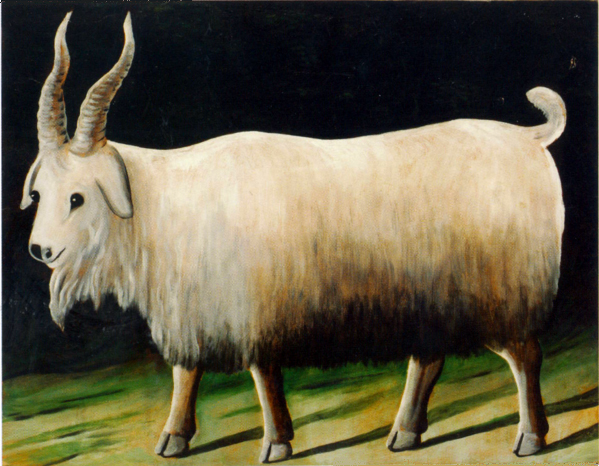How does the lighting affect the perception of the goat in this image? The lighting plays a crucial role in this artwork by casting the goat in a spotlight that seems almost theatrical. This focused illumination not only draws the viewer's attention to the goat's form and texture but also creates dramatic shadows that enhance the three-dimensional effect, making the goat appear more lifelike and central within the composition. 